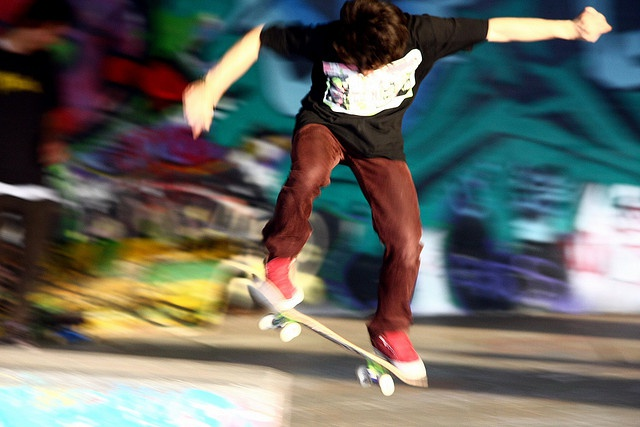Describe the objects in this image and their specific colors. I can see people in maroon, black, beige, and khaki tones and skateboard in maroon, beige, khaki, gray, and darkgray tones in this image. 